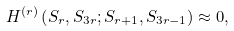Convert formula to latex. <formula><loc_0><loc_0><loc_500><loc_500>H ^ { ( r ) } \left ( S _ { r } , S _ { 3 r } ; S _ { r + 1 } , S _ { 3 r - 1 } \right ) \approx 0 ,</formula> 